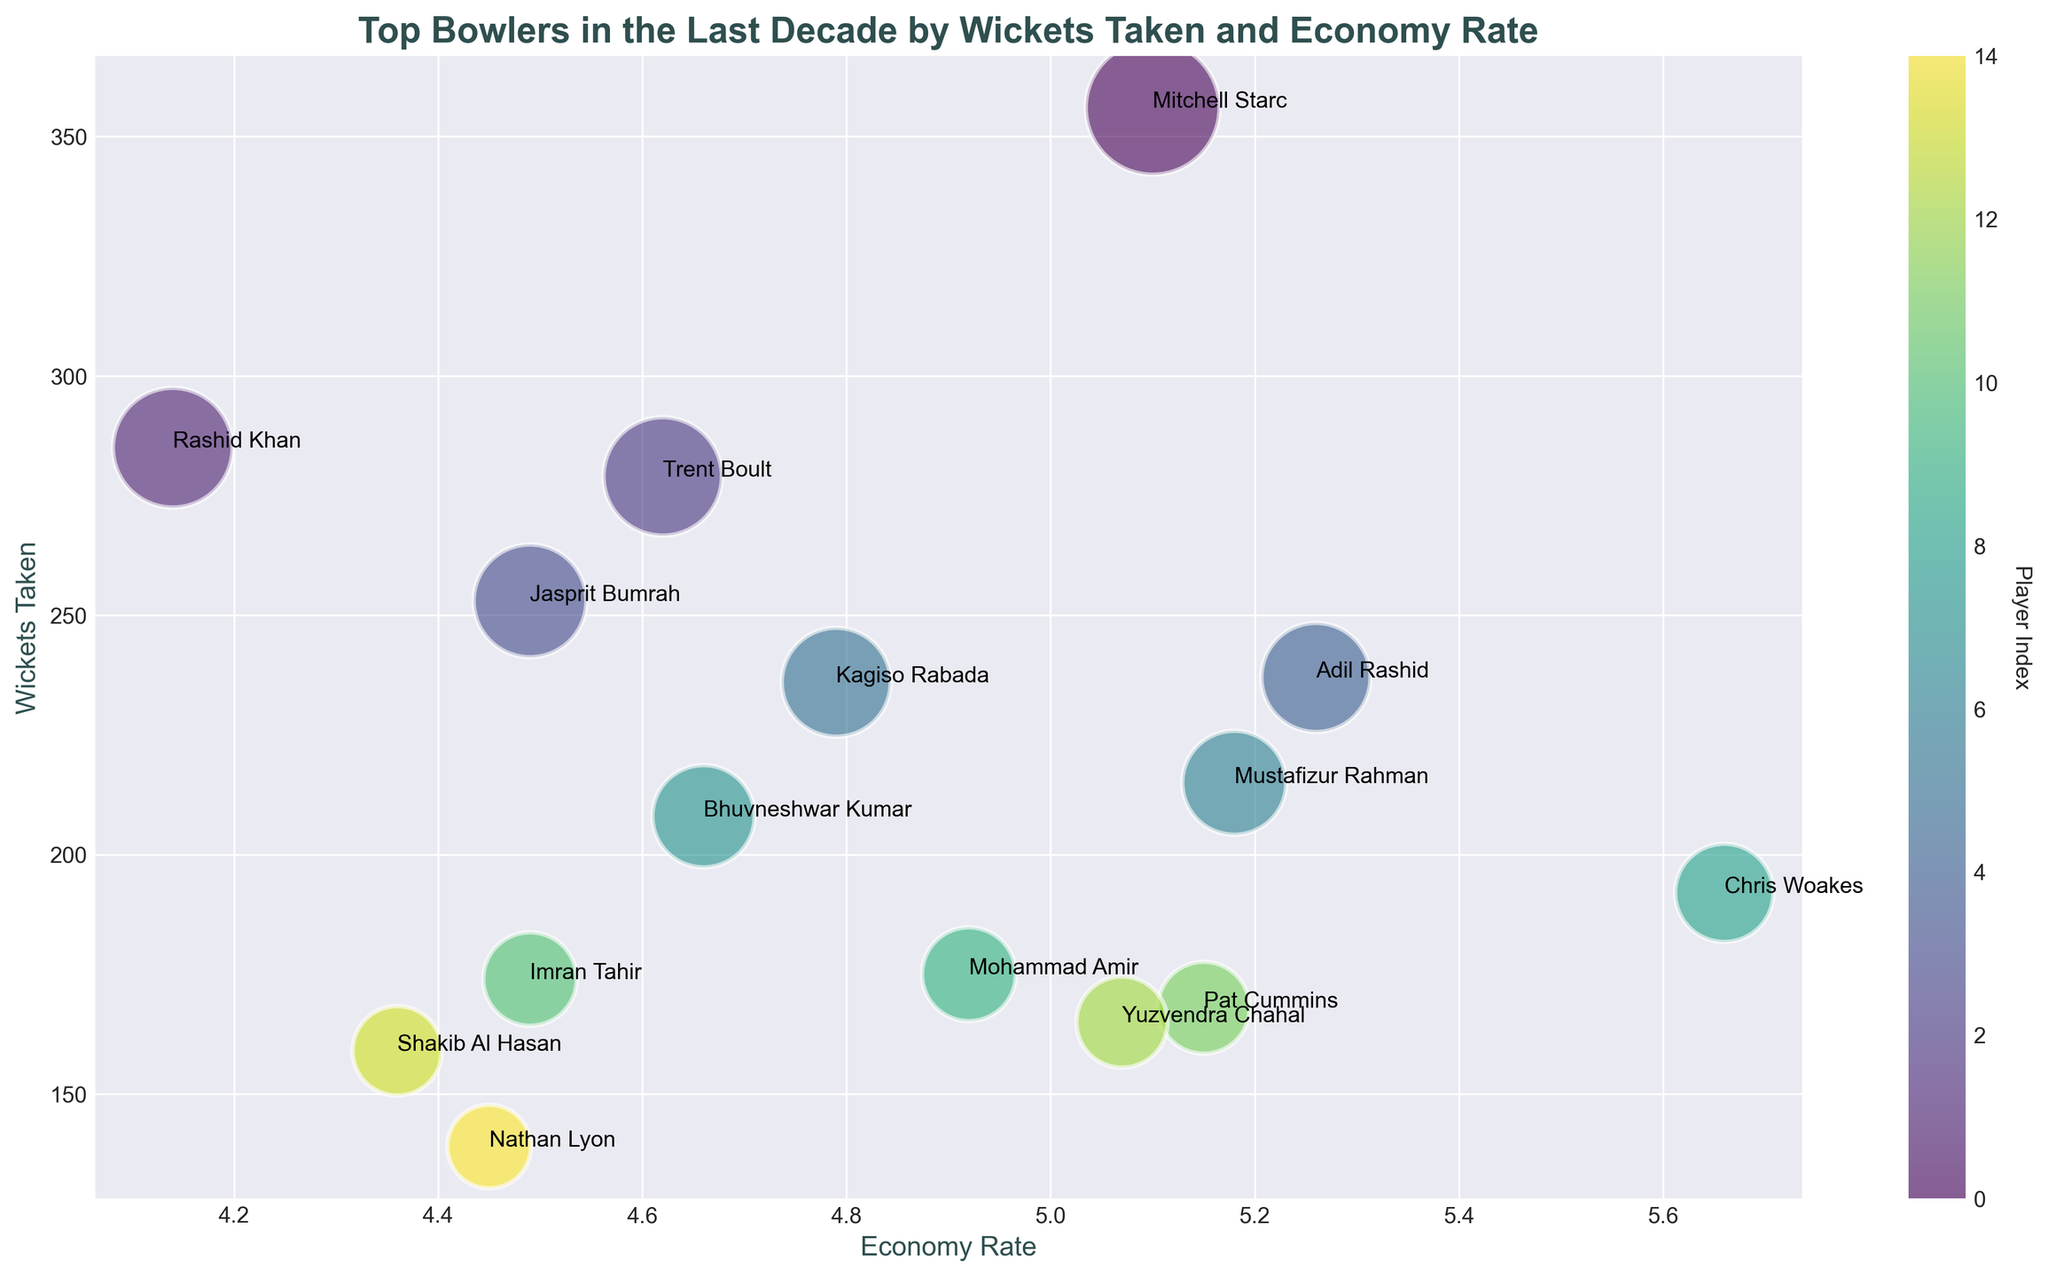What's the economy rate of the bowler with the highest number of wickets? The bowler with the highest number of wickets is Mitchell Starc with 356 wickets. By looking at the economy rate axis, Mitchell Starc has an economy rate of 5.10
Answer: 5.10 Who has a better economy rate, Rashid Khan or Jasprit Bumrah? Rashid Khan has an economy rate of 4.14 whereas Jasprit Bumrah has an economy rate of 4.49. Since 4.14 is less than 4.49, Rashid Khan has a better economy rate.
Answer: Rashid Khan Which country has the bowler with the highest economy rate in the chart? By checking the economy rate axis, Chris Woakes from England has the highest economy rate of 5.66.
Answer: England What is the average economy rate of the top two wicket-takers? The top two wicket-takers are Mitchell Starc (356 wickets) and Rashid Khan (285 wickets) with economy rates of 5.10 and 4.14 respectively. The average is calculated as (5.10 + 4.14) / 2 = 4.62
Answer: 4.62 Is there any bowler from Australia with an economy rate less than 5? Checking the economy rates of Australian bowlers (Mitchell Starc: 5.10, Pat Cummins: 5.15, Nathan Lyon: 4.45), Nathan Lyon has an economy rate of 4.45 which is less than 5.
Answer: Yes, Nathan Lyon Which bowler has the smallest bubble size and why? The bubble size represents the number of wickets taken. Mohammad Amir has the smallest bubble size as he has taken 175 wickets, which is the fewest in the chart.
Answer: Mohammad Amir Who has taken more wickets, Adil Rashid or Kagiso Rabada? Adil Rashid has taken 237 wickets while Kagiso Rabada has taken 236 wickets. Therefore, Adil Rashid has taken more wickets than Kagiso Rabada.
Answer: Adil Rashid What is the difference in wickets taken between the bowler with the highest economy rate and the bowler with the lowest economy rate? Chris Woakes has the highest economy rate (5.66) with 192 wickets, while Rashid Khan has the lowest economy rate (4.14) with 285 wickets. The difference in wickets taken is 285 - 192 = 93
Answer: 93 Which Indian bowler has the lowest economy rate and how much is it? The Indian bowlers are Jasprit Bumrah, Bhuvneshwar Kumar, and Yuzvendra Chahal. Their economy rates are 4.49, 4.66, and 5.07, respectively. Jasprit Bumrah has the lowest economy rate of 4.49.
Answer: Jasprit Bumrah, 4.49 